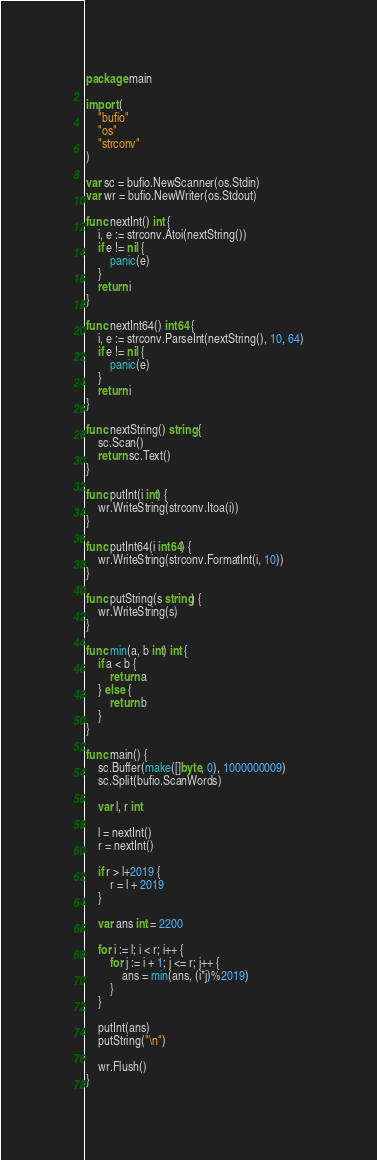<code> <loc_0><loc_0><loc_500><loc_500><_Go_>package main

import (
	"bufio"
	"os"
	"strconv"
)

var sc = bufio.NewScanner(os.Stdin)
var wr = bufio.NewWriter(os.Stdout)

func nextInt() int {
	i, e := strconv.Atoi(nextString())
	if e != nil {
		panic(e)
	}
	return i
}

func nextInt64() int64 {
	i, e := strconv.ParseInt(nextString(), 10, 64)
	if e != nil {
		panic(e)
	}
	return i
}

func nextString() string {
	sc.Scan()
	return sc.Text()
}

func putInt(i int) {
	wr.WriteString(strconv.Itoa(i))
}

func putInt64(i int64) {
	wr.WriteString(strconv.FormatInt(i, 10))
}

func putString(s string) {
	wr.WriteString(s)
}

func min(a, b int) int {
	if a < b {
		return a
	} else {
		return b
	}
}

func main() {
	sc.Buffer(make([]byte, 0), 1000000009)
	sc.Split(bufio.ScanWords)

	var l, r int

	l = nextInt()
	r = nextInt()

	if r > l+2019 {
		r = l + 2019
	}

	var ans int = 2200

	for i := l; i < r; i++ {
		for j := i + 1; j <= r; j++ {
			ans = min(ans, (i*j)%2019)
		}
	}

	putInt(ans)
	putString("\n")

	wr.Flush()
}</code> 